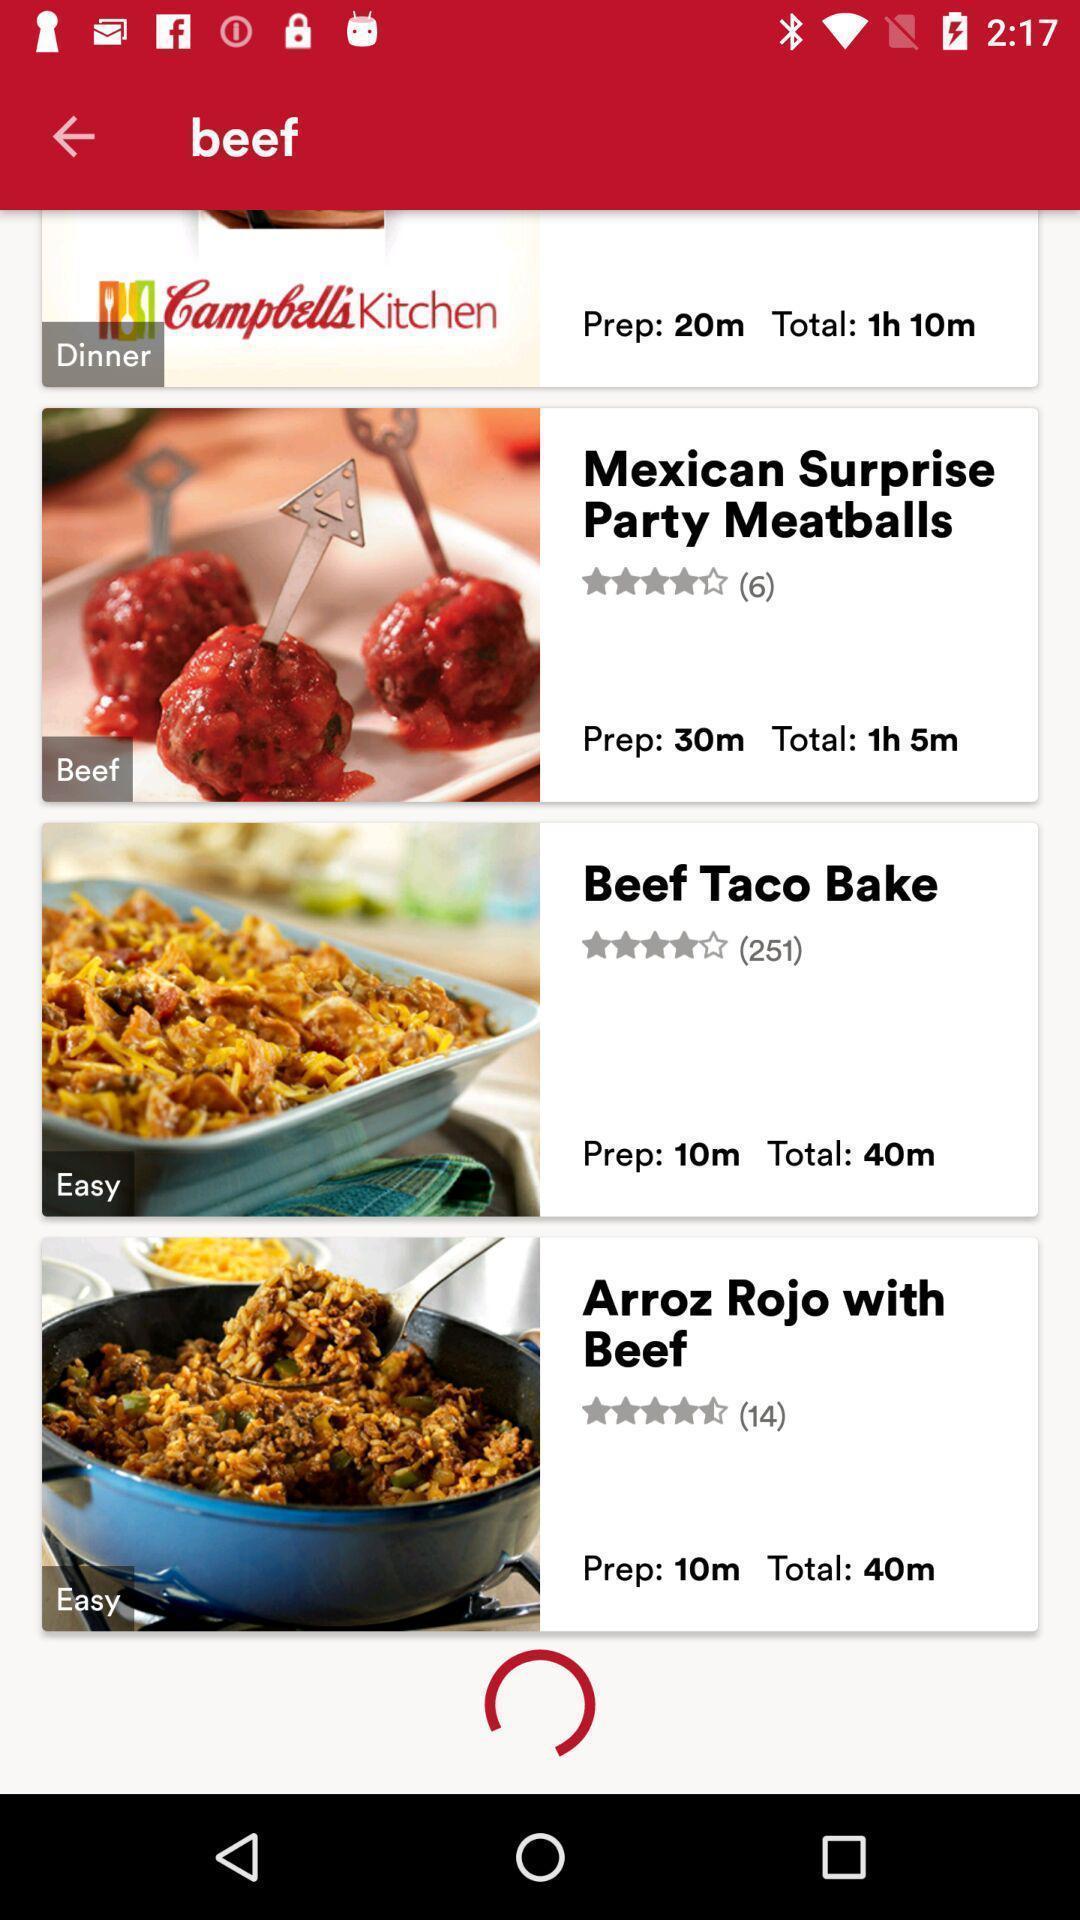Explain the elements present in this screenshot. Screen displaying the list of beef dishes. 